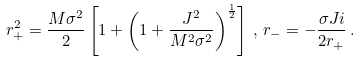<formula> <loc_0><loc_0><loc_500><loc_500>r _ { + } ^ { 2 } = \frac { M \sigma ^ { 2 } } { 2 } \left [ 1 + \left ( 1 + \frac { J ^ { 2 } } { M ^ { 2 } \sigma ^ { 2 } } \right ) ^ { \frac { 1 } { 2 } } \right ] \, , \, r _ { - } = - \frac { \sigma J i } { 2 r _ { + } } \, .</formula> 